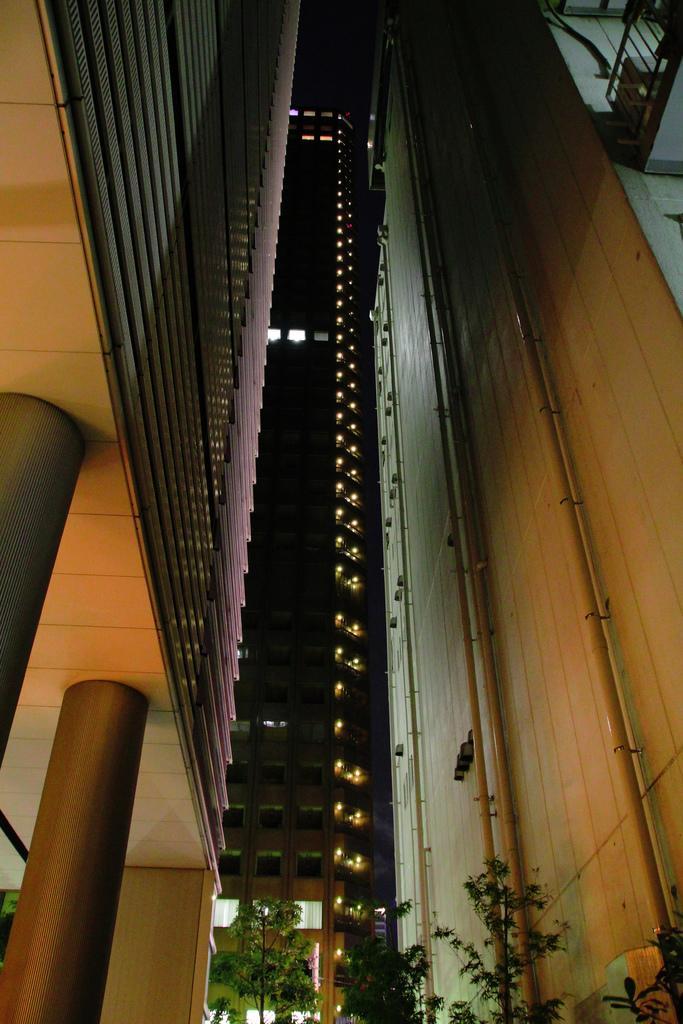Describe this image in one or two sentences. In this image we can see a building with pillar, windows, pipes and a wall. We can also see a some plants. 